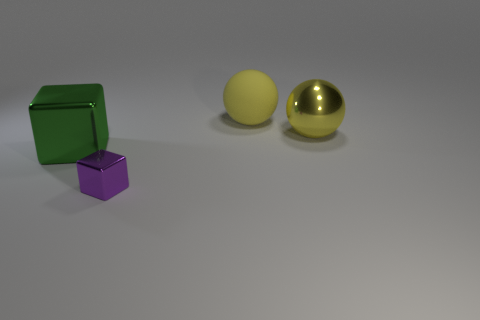There is a yellow sphere that is behind the yellow shiny ball; what size is it?
Keep it short and to the point. Large. Is the color of the rubber thing the same as the small metallic thing?
Provide a short and direct response. No. Is there any other thing that is the same shape as the large green metallic thing?
Your answer should be very brief. Yes. There is a big object that is the same color as the matte sphere; what is it made of?
Give a very brief answer. Metal. Is the number of yellow rubber balls that are in front of the rubber sphere the same as the number of brown shiny objects?
Give a very brief answer. Yes. There is a small purple thing; are there any shiny cubes on the left side of it?
Your answer should be very brief. Yes. Is the shape of the large yellow metallic thing the same as the rubber object that is to the right of the purple object?
Make the answer very short. Yes. What is the color of the large thing that is made of the same material as the green block?
Provide a succinct answer. Yellow. What is the color of the big metallic ball?
Provide a succinct answer. Yellow. Does the small purple block have the same material as the object on the left side of the tiny metallic thing?
Provide a succinct answer. Yes. 